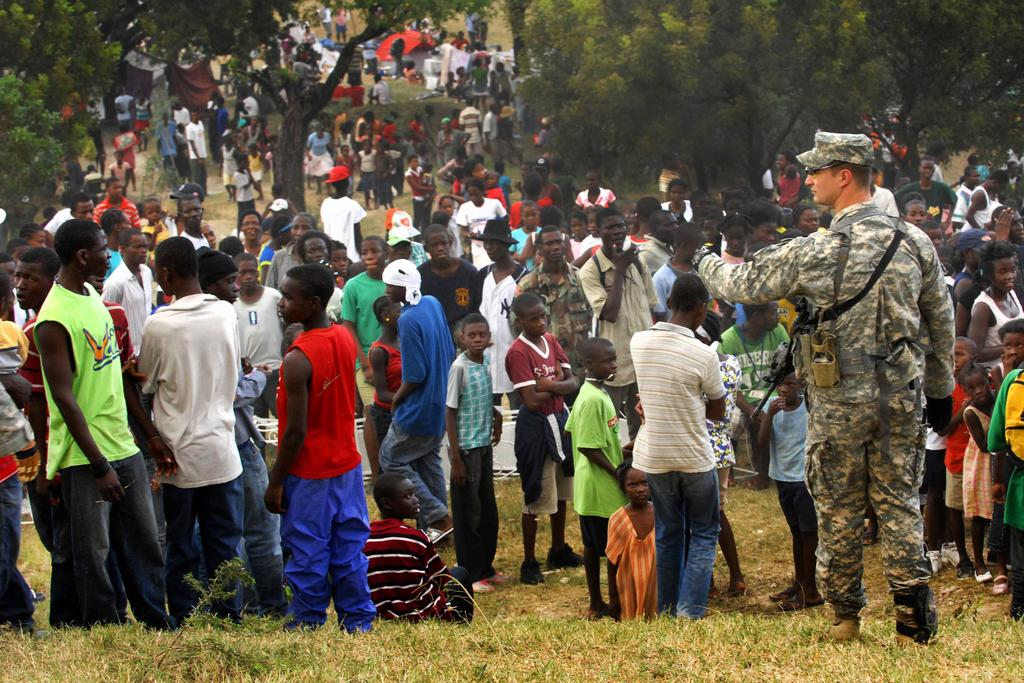What is happening in the image? There is a group of people standing in the image. What can be seen in the background of the image? There are trees in the background of the image. What is the color of the trees? The trees are green in color. Can you describe the person in front? There is a person in front wearing a green uniform. What is the boundary of the view in the image? The image does not have a boundary, as it is a photograph or digital representation of a scene. How does the person in the green uniform aid in the digestion of the group? There is no information about digestion in the image, and the person in the green uniform is not shown interacting with the group in any way. 